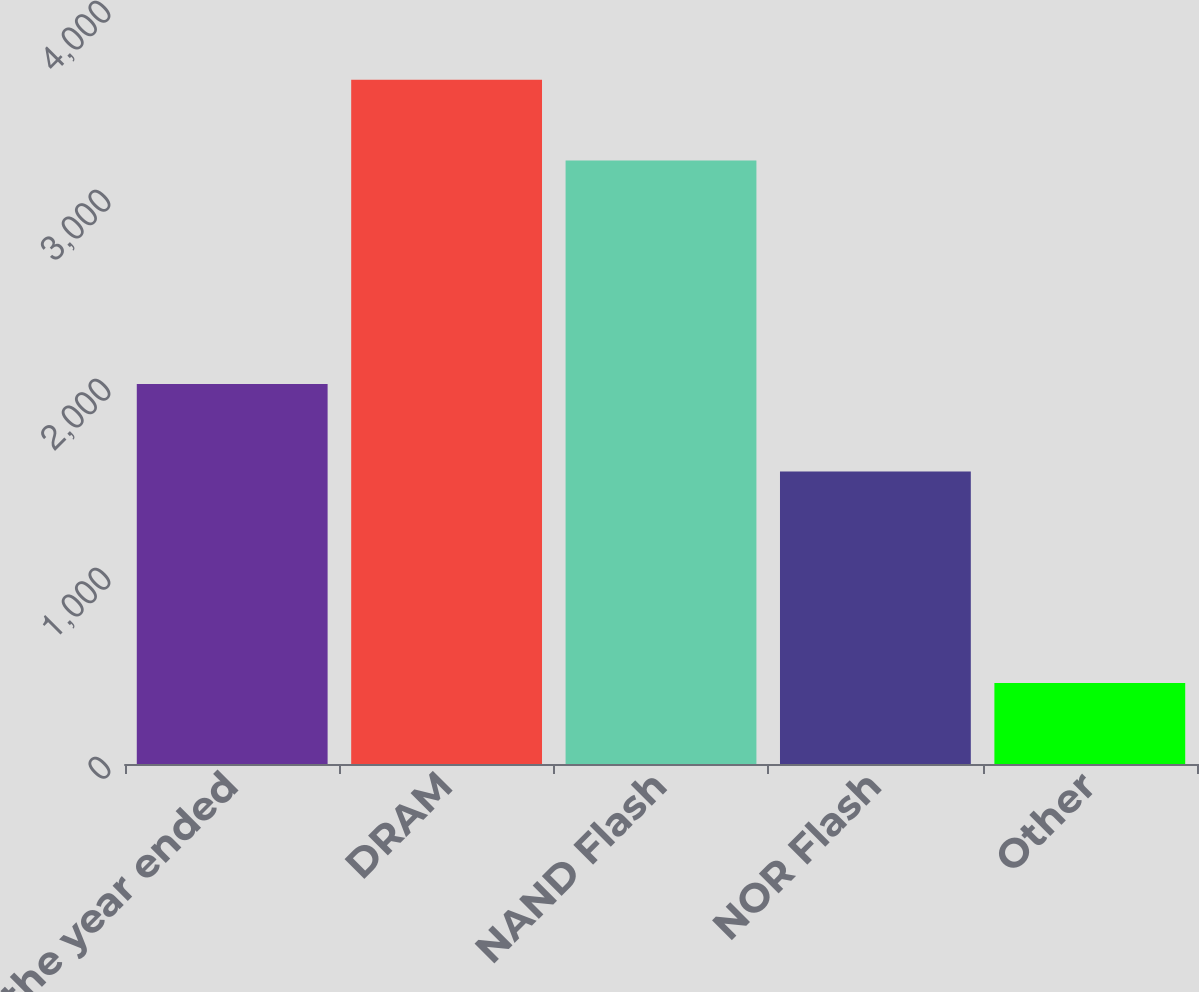Convert chart to OTSL. <chart><loc_0><loc_0><loc_500><loc_500><bar_chart><fcel>For the year ended<fcel>DRAM<fcel>NAND Flash<fcel>NOR Flash<fcel>Other<nl><fcel>2011<fcel>3620<fcel>3193<fcel>1547<fcel>428<nl></chart> 